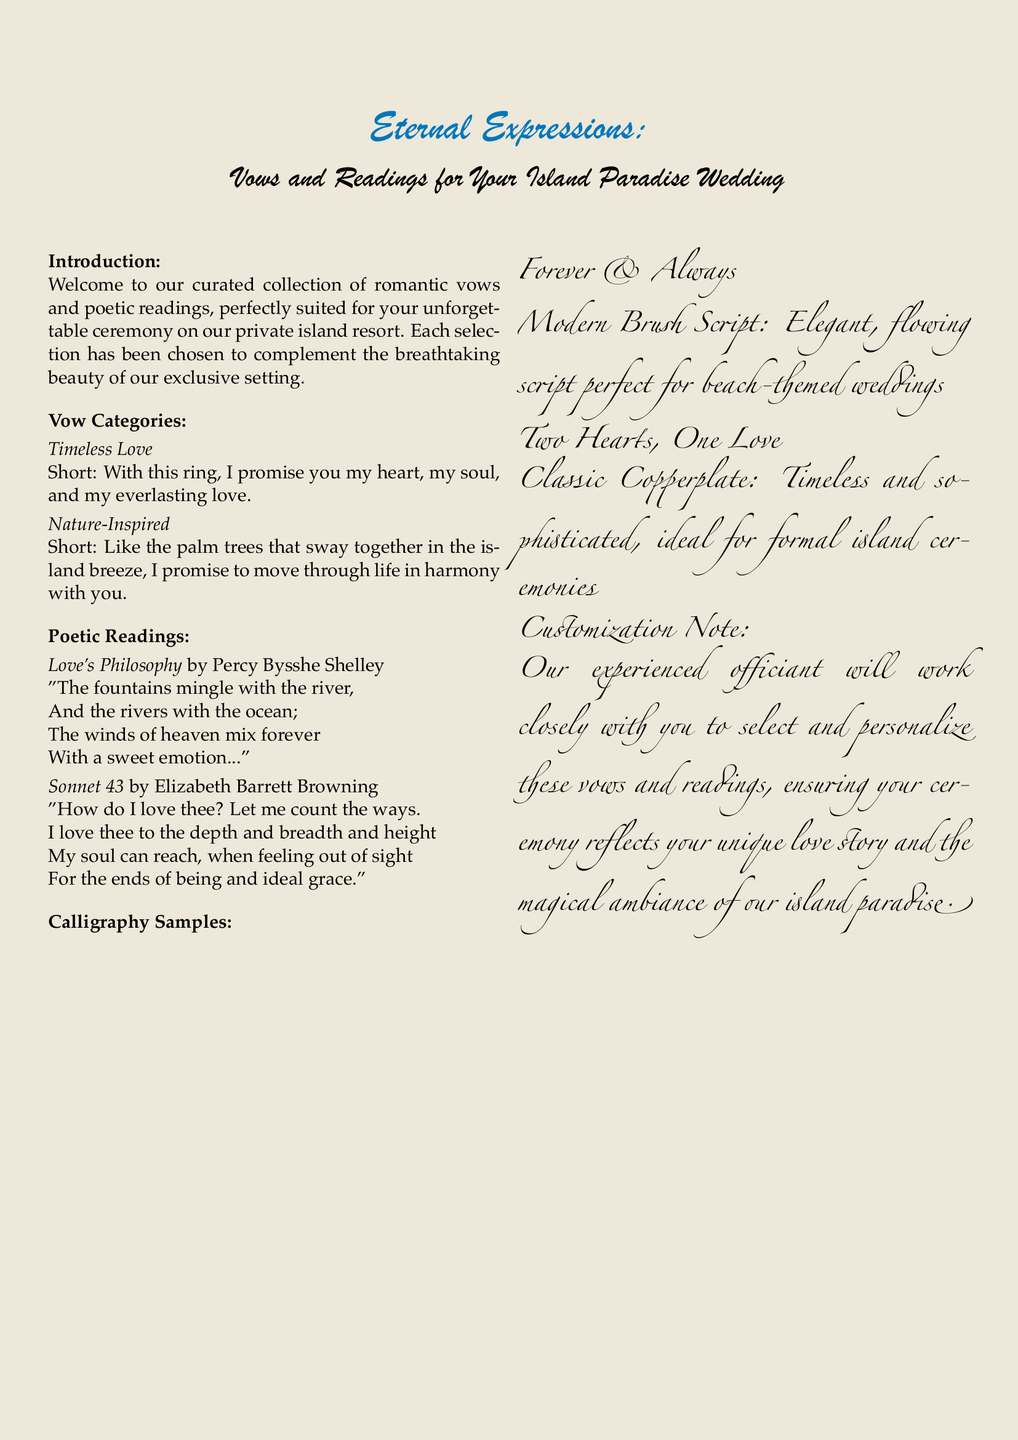What is the title of the catalog? The title is prominently displayed at the top of the document, indicating the focus of the content.
Answer: Eternal Expressions What is the theme of the vows? The document categorizes vows by themes, which reflects their nature and intention.
Answer: Romantic How many categories of vows are presented? The sections in the document mention different categories of vows available for selection.
Answer: Two Who is the author of "Love's Philosophy"? The document provides the names of authors for the poetic readings included.
Answer: Percy Bysshe Shelley What type of calligraphy is used for "Forever & Always"? The document specifies different styles of calligraphy samples for the quotes.
Answer: Modern Brush Script What is one example of a nature-inspired vow? The content includes specific examples of vows under the nature-inspired category.
Answer: Like the palm trees that sway together in the island breeze, I promise to move through life in harmony with you What does the customization note emphasize? The note elaborates on how the vows and readings can be tailored to individual preferences.
Answer: Personalization Which font is used for the main text? The document uses specific fonts to present its content aesthetically.
Answer: Palatino 